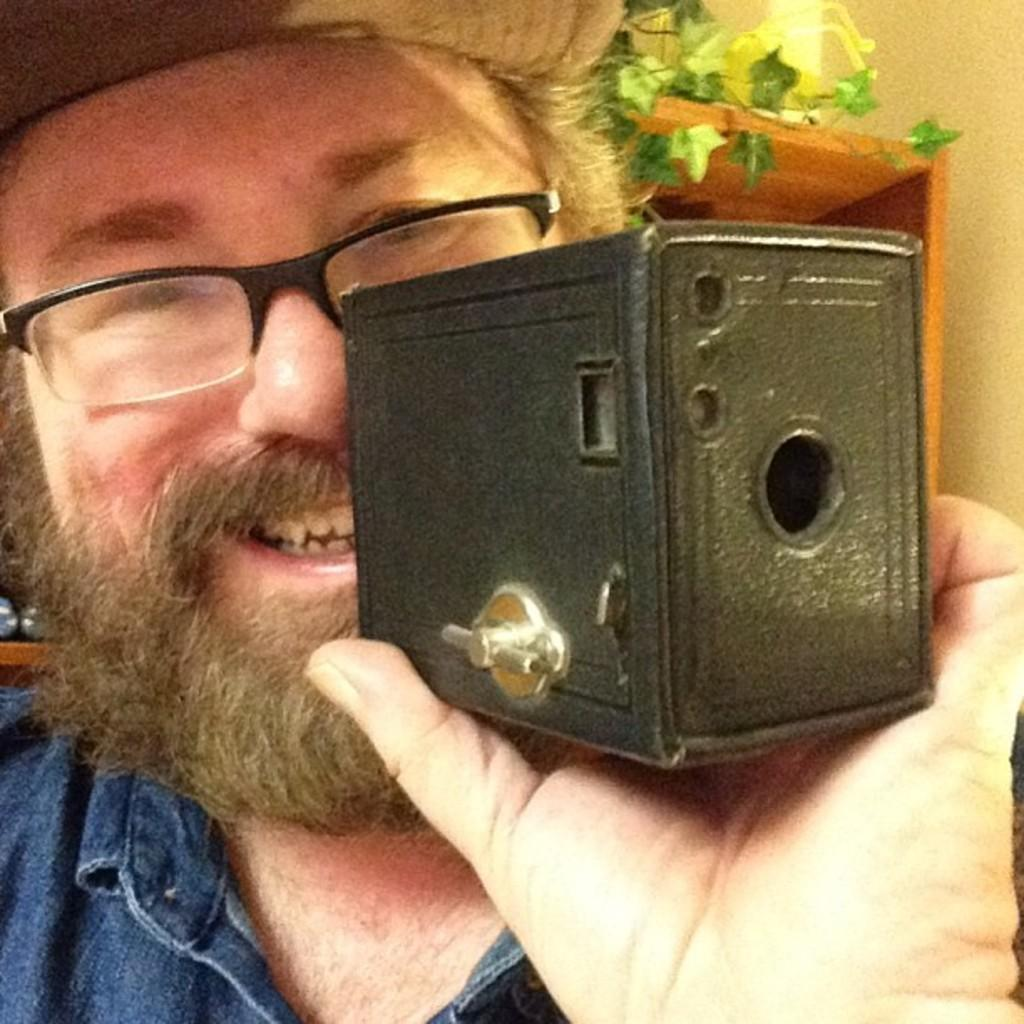What is the main subject of the image? There is a person in the image. What is the person holding in their hand? The person is holding something in their hand, but the specific object is not mentioned in the facts. What is the person's emotional state in the image? The person is laughing. What accessories is the person wearing? The person is wearing spectacles and a cap. What type of vegetation is visible in the image? There is a plant visible in the image. What type of comfort can be seen in the image? There is no specific comfort mentioned or visible in the image. What type of sticks are being used by the person in the image? There is no mention of sticks in the image; the person is holding something else in their hand. 